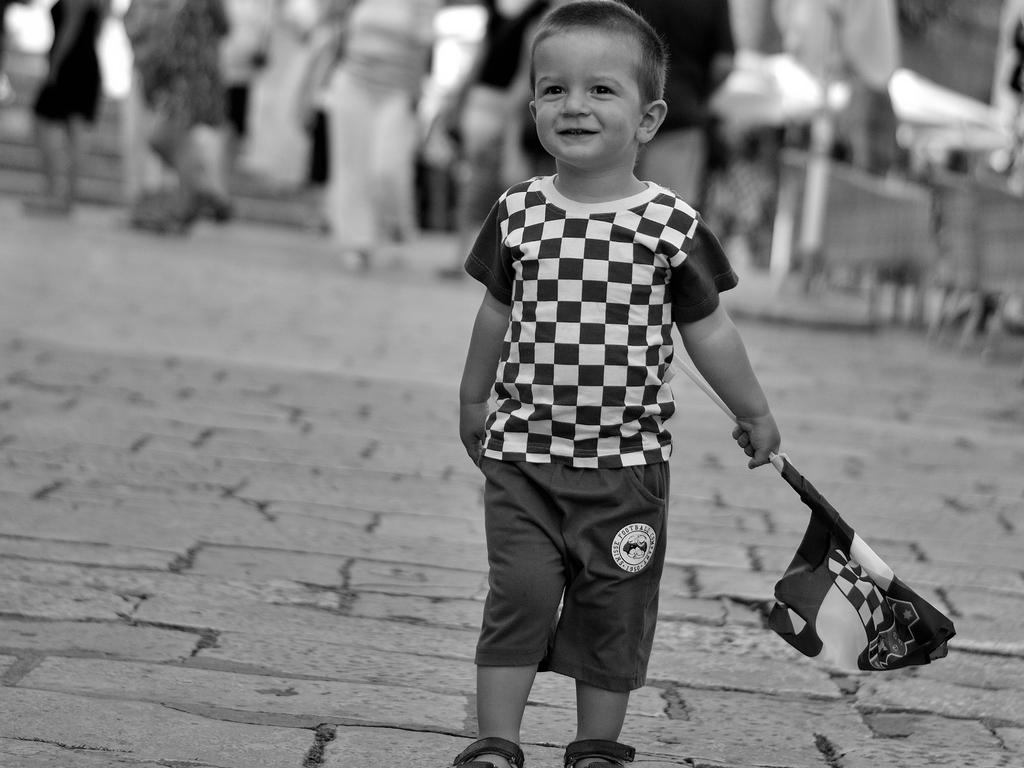What is the main subject of the image? The main subject of the image is a kid. What is the kid doing in the image? The kid is standing and holding a flag. What can be seen in the background of the image? There are people walking in the background of the image. Can you tell me how many snakes are slithering around the kid in the image? There are no snakes present in the image; the kid is holding a flag. 